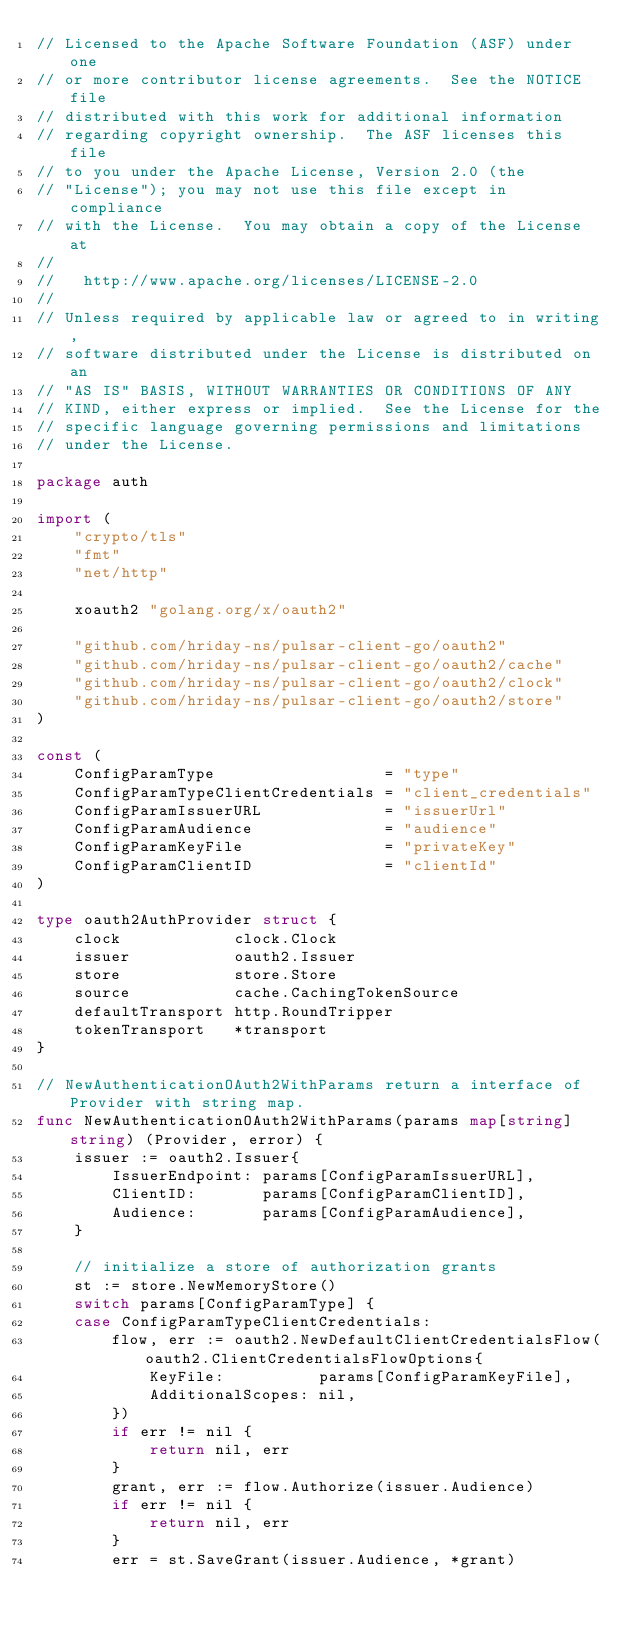Convert code to text. <code><loc_0><loc_0><loc_500><loc_500><_Go_>// Licensed to the Apache Software Foundation (ASF) under one
// or more contributor license agreements.  See the NOTICE file
// distributed with this work for additional information
// regarding copyright ownership.  The ASF licenses this file
// to you under the Apache License, Version 2.0 (the
// "License"); you may not use this file except in compliance
// with the License.  You may obtain a copy of the License at
//
//   http://www.apache.org/licenses/LICENSE-2.0
//
// Unless required by applicable law or agreed to in writing,
// software distributed under the License is distributed on an
// "AS IS" BASIS, WITHOUT WARRANTIES OR CONDITIONS OF ANY
// KIND, either express or implied.  See the License for the
// specific language governing permissions and limitations
// under the License.

package auth

import (
	"crypto/tls"
	"fmt"
	"net/http"

	xoauth2 "golang.org/x/oauth2"

	"github.com/hriday-ns/pulsar-client-go/oauth2"
	"github.com/hriday-ns/pulsar-client-go/oauth2/cache"
	"github.com/hriday-ns/pulsar-client-go/oauth2/clock"
	"github.com/hriday-ns/pulsar-client-go/oauth2/store"
)

const (
	ConfigParamType                  = "type"
	ConfigParamTypeClientCredentials = "client_credentials"
	ConfigParamIssuerURL             = "issuerUrl"
	ConfigParamAudience              = "audience"
	ConfigParamKeyFile               = "privateKey"
	ConfigParamClientID              = "clientId"
)

type oauth2AuthProvider struct {
	clock            clock.Clock
	issuer           oauth2.Issuer
	store            store.Store
	source           cache.CachingTokenSource
	defaultTransport http.RoundTripper
	tokenTransport   *transport
}

// NewAuthenticationOAuth2WithParams return a interface of Provider with string map.
func NewAuthenticationOAuth2WithParams(params map[string]string) (Provider, error) {
	issuer := oauth2.Issuer{
		IssuerEndpoint: params[ConfigParamIssuerURL],
		ClientID:       params[ConfigParamClientID],
		Audience:       params[ConfigParamAudience],
	}

	// initialize a store of authorization grants
	st := store.NewMemoryStore()
	switch params[ConfigParamType] {
	case ConfigParamTypeClientCredentials:
		flow, err := oauth2.NewDefaultClientCredentialsFlow(oauth2.ClientCredentialsFlowOptions{
			KeyFile:          params[ConfigParamKeyFile],
			AdditionalScopes: nil,
		})
		if err != nil {
			return nil, err
		}
		grant, err := flow.Authorize(issuer.Audience)
		if err != nil {
			return nil, err
		}
		err = st.SaveGrant(issuer.Audience, *grant)</code> 